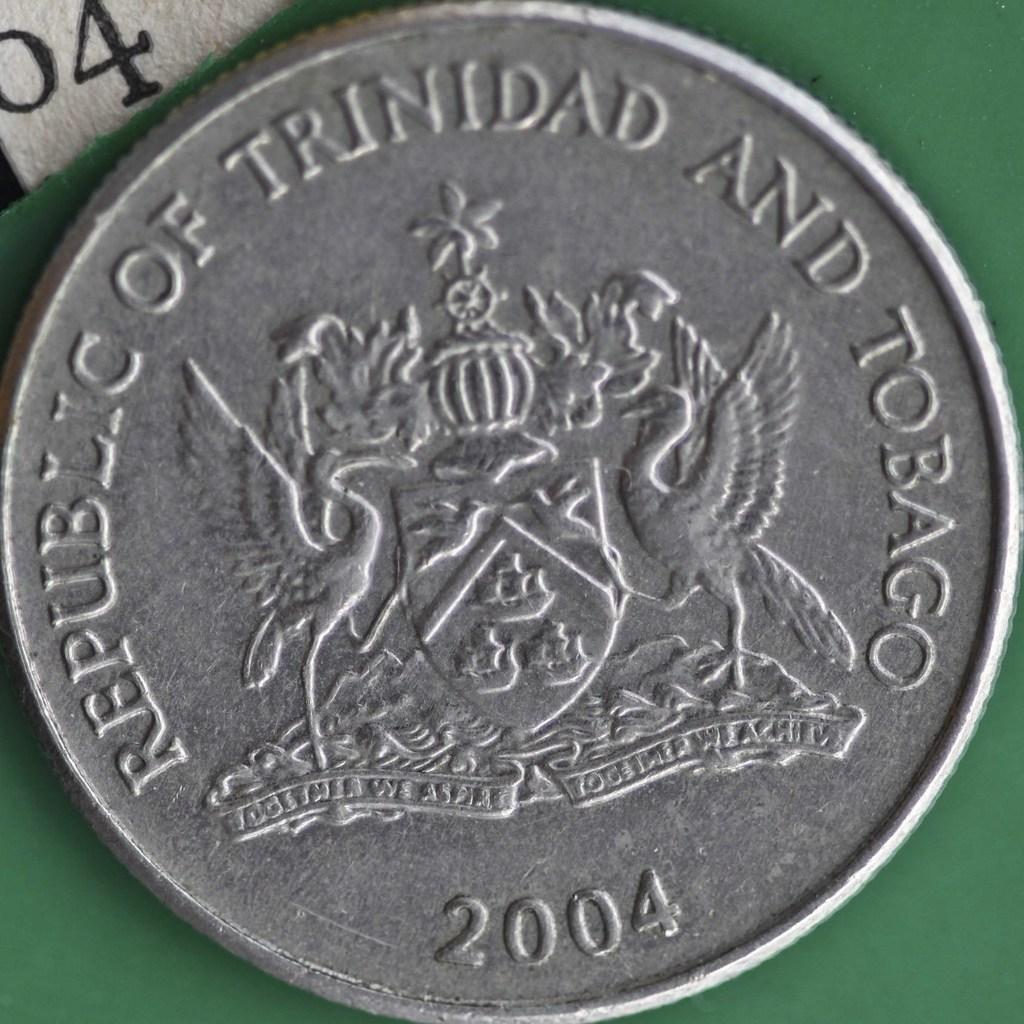<image>
Provide a brief description of the given image. Silver coin with a symbol on it and says "Republic of Trinidad". 